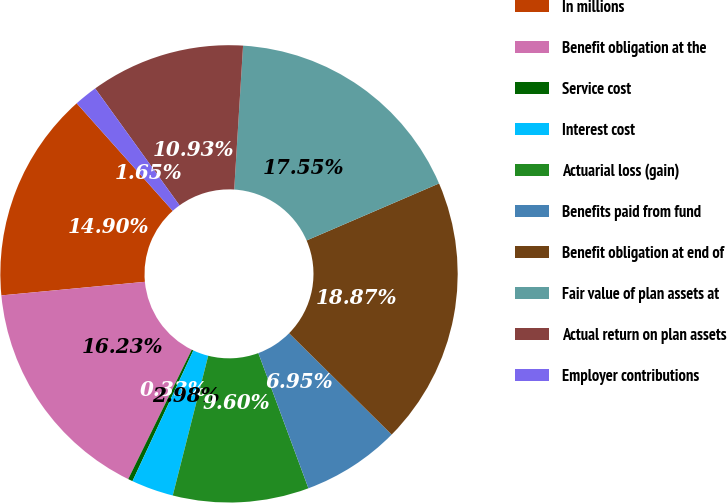<chart> <loc_0><loc_0><loc_500><loc_500><pie_chart><fcel>In millions<fcel>Benefit obligation at the<fcel>Service cost<fcel>Interest cost<fcel>Actuarial loss (gain)<fcel>Benefits paid from fund<fcel>Benefit obligation at end of<fcel>Fair value of plan assets at<fcel>Actual return on plan assets<fcel>Employer contributions<nl><fcel>14.9%<fcel>16.23%<fcel>0.33%<fcel>2.98%<fcel>9.6%<fcel>6.95%<fcel>18.87%<fcel>17.55%<fcel>10.93%<fcel>1.65%<nl></chart> 